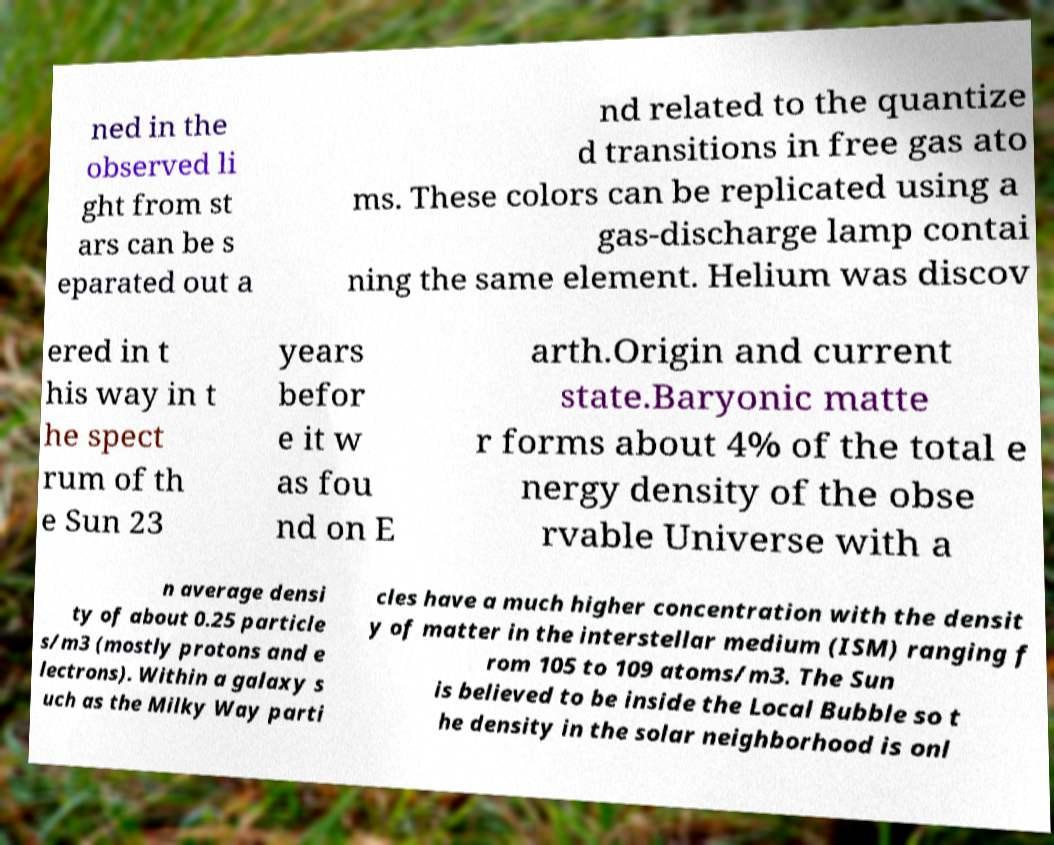Can you accurately transcribe the text from the provided image for me? ned in the observed li ght from st ars can be s eparated out a nd related to the quantize d transitions in free gas ato ms. These colors can be replicated using a gas-discharge lamp contai ning the same element. Helium was discov ered in t his way in t he spect rum of th e Sun 23 years befor e it w as fou nd on E arth.Origin and current state.Baryonic matte r forms about 4% of the total e nergy density of the obse rvable Universe with a n average densi ty of about 0.25 particle s/m3 (mostly protons and e lectrons). Within a galaxy s uch as the Milky Way parti cles have a much higher concentration with the densit y of matter in the interstellar medium (ISM) ranging f rom 105 to 109 atoms/m3. The Sun is believed to be inside the Local Bubble so t he density in the solar neighborhood is onl 